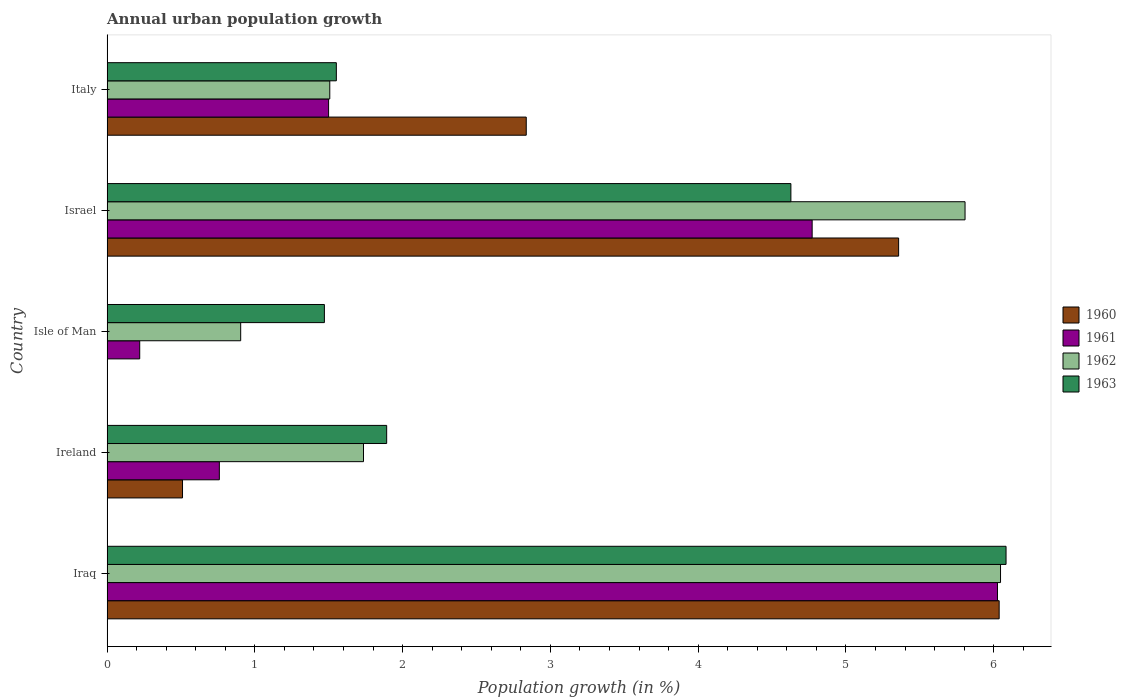Are the number of bars per tick equal to the number of legend labels?
Offer a very short reply. No. Are the number of bars on each tick of the Y-axis equal?
Offer a very short reply. No. How many bars are there on the 1st tick from the bottom?
Give a very brief answer. 4. What is the percentage of urban population growth in 1960 in Italy?
Your answer should be very brief. 2.84. Across all countries, what is the maximum percentage of urban population growth in 1962?
Provide a succinct answer. 6.05. Across all countries, what is the minimum percentage of urban population growth in 1962?
Your answer should be very brief. 0.9. In which country was the percentage of urban population growth in 1960 maximum?
Provide a succinct answer. Iraq. What is the total percentage of urban population growth in 1963 in the graph?
Offer a very short reply. 15.62. What is the difference between the percentage of urban population growth in 1961 in Ireland and that in Isle of Man?
Offer a very short reply. 0.54. What is the difference between the percentage of urban population growth in 1961 in Italy and the percentage of urban population growth in 1960 in Iraq?
Provide a short and direct response. -4.54. What is the average percentage of urban population growth in 1962 per country?
Make the answer very short. 3.2. What is the difference between the percentage of urban population growth in 1963 and percentage of urban population growth in 1961 in Ireland?
Give a very brief answer. 1.13. What is the ratio of the percentage of urban population growth in 1963 in Iraq to that in Ireland?
Keep it short and to the point. 3.22. Is the percentage of urban population growth in 1962 in Isle of Man less than that in Italy?
Your response must be concise. Yes. What is the difference between the highest and the second highest percentage of urban population growth in 1960?
Provide a short and direct response. 0.68. What is the difference between the highest and the lowest percentage of urban population growth in 1963?
Give a very brief answer. 4.61. Is the sum of the percentage of urban population growth in 1962 in Ireland and Israel greater than the maximum percentage of urban population growth in 1963 across all countries?
Ensure brevity in your answer.  Yes. Is it the case that in every country, the sum of the percentage of urban population growth in 1960 and percentage of urban population growth in 1963 is greater than the percentage of urban population growth in 1962?
Your response must be concise. Yes. Are all the bars in the graph horizontal?
Make the answer very short. Yes. How many countries are there in the graph?
Give a very brief answer. 5. What is the difference between two consecutive major ticks on the X-axis?
Provide a short and direct response. 1. How are the legend labels stacked?
Give a very brief answer. Vertical. What is the title of the graph?
Provide a succinct answer. Annual urban population growth. What is the label or title of the X-axis?
Give a very brief answer. Population growth (in %). What is the Population growth (in %) of 1960 in Iraq?
Provide a short and direct response. 6.04. What is the Population growth (in %) in 1961 in Iraq?
Provide a succinct answer. 6.03. What is the Population growth (in %) of 1962 in Iraq?
Offer a terse response. 6.05. What is the Population growth (in %) in 1963 in Iraq?
Offer a terse response. 6.08. What is the Population growth (in %) of 1960 in Ireland?
Your answer should be compact. 0.51. What is the Population growth (in %) in 1961 in Ireland?
Give a very brief answer. 0.76. What is the Population growth (in %) in 1962 in Ireland?
Offer a very short reply. 1.74. What is the Population growth (in %) in 1963 in Ireland?
Provide a succinct answer. 1.89. What is the Population growth (in %) in 1960 in Isle of Man?
Ensure brevity in your answer.  0. What is the Population growth (in %) in 1961 in Isle of Man?
Provide a succinct answer. 0.22. What is the Population growth (in %) of 1962 in Isle of Man?
Give a very brief answer. 0.9. What is the Population growth (in %) of 1963 in Isle of Man?
Your answer should be compact. 1.47. What is the Population growth (in %) of 1960 in Israel?
Your answer should be compact. 5.36. What is the Population growth (in %) in 1961 in Israel?
Your answer should be very brief. 4.77. What is the Population growth (in %) in 1962 in Israel?
Provide a succinct answer. 5.81. What is the Population growth (in %) in 1963 in Israel?
Give a very brief answer. 4.63. What is the Population growth (in %) in 1960 in Italy?
Provide a succinct answer. 2.84. What is the Population growth (in %) in 1961 in Italy?
Provide a short and direct response. 1.5. What is the Population growth (in %) in 1962 in Italy?
Offer a very short reply. 1.51. What is the Population growth (in %) of 1963 in Italy?
Your answer should be very brief. 1.55. Across all countries, what is the maximum Population growth (in %) in 1960?
Your answer should be very brief. 6.04. Across all countries, what is the maximum Population growth (in %) of 1961?
Make the answer very short. 6.03. Across all countries, what is the maximum Population growth (in %) of 1962?
Make the answer very short. 6.05. Across all countries, what is the maximum Population growth (in %) of 1963?
Provide a short and direct response. 6.08. Across all countries, what is the minimum Population growth (in %) of 1960?
Offer a terse response. 0. Across all countries, what is the minimum Population growth (in %) in 1961?
Keep it short and to the point. 0.22. Across all countries, what is the minimum Population growth (in %) in 1962?
Ensure brevity in your answer.  0.9. Across all countries, what is the minimum Population growth (in %) of 1963?
Keep it short and to the point. 1.47. What is the total Population growth (in %) of 1960 in the graph?
Give a very brief answer. 14.74. What is the total Population growth (in %) in 1961 in the graph?
Keep it short and to the point. 13.28. What is the total Population growth (in %) of 1962 in the graph?
Give a very brief answer. 16. What is the total Population growth (in %) of 1963 in the graph?
Ensure brevity in your answer.  15.62. What is the difference between the Population growth (in %) of 1960 in Iraq and that in Ireland?
Keep it short and to the point. 5.53. What is the difference between the Population growth (in %) of 1961 in Iraq and that in Ireland?
Make the answer very short. 5.27. What is the difference between the Population growth (in %) in 1962 in Iraq and that in Ireland?
Your answer should be very brief. 4.31. What is the difference between the Population growth (in %) of 1963 in Iraq and that in Ireland?
Keep it short and to the point. 4.19. What is the difference between the Population growth (in %) in 1961 in Iraq and that in Isle of Man?
Keep it short and to the point. 5.8. What is the difference between the Population growth (in %) in 1962 in Iraq and that in Isle of Man?
Provide a short and direct response. 5.14. What is the difference between the Population growth (in %) in 1963 in Iraq and that in Isle of Man?
Offer a very short reply. 4.61. What is the difference between the Population growth (in %) of 1960 in Iraq and that in Israel?
Your response must be concise. 0.68. What is the difference between the Population growth (in %) in 1961 in Iraq and that in Israel?
Offer a terse response. 1.25. What is the difference between the Population growth (in %) of 1962 in Iraq and that in Israel?
Provide a succinct answer. 0.24. What is the difference between the Population growth (in %) of 1963 in Iraq and that in Israel?
Provide a succinct answer. 1.46. What is the difference between the Population growth (in %) of 1960 in Iraq and that in Italy?
Make the answer very short. 3.2. What is the difference between the Population growth (in %) of 1961 in Iraq and that in Italy?
Make the answer very short. 4.53. What is the difference between the Population growth (in %) of 1962 in Iraq and that in Italy?
Provide a succinct answer. 4.54. What is the difference between the Population growth (in %) of 1963 in Iraq and that in Italy?
Your response must be concise. 4.53. What is the difference between the Population growth (in %) in 1961 in Ireland and that in Isle of Man?
Your answer should be compact. 0.54. What is the difference between the Population growth (in %) in 1962 in Ireland and that in Isle of Man?
Your answer should be compact. 0.83. What is the difference between the Population growth (in %) of 1963 in Ireland and that in Isle of Man?
Make the answer very short. 0.42. What is the difference between the Population growth (in %) of 1960 in Ireland and that in Israel?
Make the answer very short. -4.85. What is the difference between the Population growth (in %) in 1961 in Ireland and that in Israel?
Make the answer very short. -4.01. What is the difference between the Population growth (in %) of 1962 in Ireland and that in Israel?
Ensure brevity in your answer.  -4.07. What is the difference between the Population growth (in %) of 1963 in Ireland and that in Israel?
Offer a terse response. -2.74. What is the difference between the Population growth (in %) in 1960 in Ireland and that in Italy?
Your answer should be very brief. -2.33. What is the difference between the Population growth (in %) of 1961 in Ireland and that in Italy?
Your response must be concise. -0.74. What is the difference between the Population growth (in %) of 1962 in Ireland and that in Italy?
Provide a short and direct response. 0.23. What is the difference between the Population growth (in %) of 1963 in Ireland and that in Italy?
Provide a short and direct response. 0.34. What is the difference between the Population growth (in %) in 1961 in Isle of Man and that in Israel?
Give a very brief answer. -4.55. What is the difference between the Population growth (in %) of 1962 in Isle of Man and that in Israel?
Make the answer very short. -4.9. What is the difference between the Population growth (in %) in 1963 in Isle of Man and that in Israel?
Give a very brief answer. -3.16. What is the difference between the Population growth (in %) in 1961 in Isle of Man and that in Italy?
Make the answer very short. -1.28. What is the difference between the Population growth (in %) in 1962 in Isle of Man and that in Italy?
Provide a succinct answer. -0.6. What is the difference between the Population growth (in %) in 1963 in Isle of Man and that in Italy?
Your response must be concise. -0.08. What is the difference between the Population growth (in %) in 1960 in Israel and that in Italy?
Your response must be concise. 2.52. What is the difference between the Population growth (in %) of 1961 in Israel and that in Italy?
Provide a short and direct response. 3.27. What is the difference between the Population growth (in %) of 1962 in Israel and that in Italy?
Make the answer very short. 4.3. What is the difference between the Population growth (in %) in 1963 in Israel and that in Italy?
Your response must be concise. 3.08. What is the difference between the Population growth (in %) in 1960 in Iraq and the Population growth (in %) in 1961 in Ireland?
Your answer should be very brief. 5.28. What is the difference between the Population growth (in %) of 1960 in Iraq and the Population growth (in %) of 1962 in Ireland?
Give a very brief answer. 4.3. What is the difference between the Population growth (in %) in 1960 in Iraq and the Population growth (in %) in 1963 in Ireland?
Offer a very short reply. 4.14. What is the difference between the Population growth (in %) of 1961 in Iraq and the Population growth (in %) of 1962 in Ireland?
Your response must be concise. 4.29. What is the difference between the Population growth (in %) of 1961 in Iraq and the Population growth (in %) of 1963 in Ireland?
Offer a terse response. 4.13. What is the difference between the Population growth (in %) of 1962 in Iraq and the Population growth (in %) of 1963 in Ireland?
Ensure brevity in your answer.  4.15. What is the difference between the Population growth (in %) in 1960 in Iraq and the Population growth (in %) in 1961 in Isle of Man?
Offer a terse response. 5.82. What is the difference between the Population growth (in %) of 1960 in Iraq and the Population growth (in %) of 1962 in Isle of Man?
Your response must be concise. 5.13. What is the difference between the Population growth (in %) of 1960 in Iraq and the Population growth (in %) of 1963 in Isle of Man?
Offer a very short reply. 4.57. What is the difference between the Population growth (in %) of 1961 in Iraq and the Population growth (in %) of 1962 in Isle of Man?
Your answer should be compact. 5.12. What is the difference between the Population growth (in %) in 1961 in Iraq and the Population growth (in %) in 1963 in Isle of Man?
Offer a terse response. 4.55. What is the difference between the Population growth (in %) in 1962 in Iraq and the Population growth (in %) in 1963 in Isle of Man?
Your answer should be very brief. 4.58. What is the difference between the Population growth (in %) in 1960 in Iraq and the Population growth (in %) in 1961 in Israel?
Offer a very short reply. 1.27. What is the difference between the Population growth (in %) in 1960 in Iraq and the Population growth (in %) in 1962 in Israel?
Your response must be concise. 0.23. What is the difference between the Population growth (in %) of 1960 in Iraq and the Population growth (in %) of 1963 in Israel?
Your answer should be compact. 1.41. What is the difference between the Population growth (in %) of 1961 in Iraq and the Population growth (in %) of 1962 in Israel?
Make the answer very short. 0.22. What is the difference between the Population growth (in %) of 1961 in Iraq and the Population growth (in %) of 1963 in Israel?
Offer a terse response. 1.4. What is the difference between the Population growth (in %) in 1962 in Iraq and the Population growth (in %) in 1963 in Israel?
Ensure brevity in your answer.  1.42. What is the difference between the Population growth (in %) in 1960 in Iraq and the Population growth (in %) in 1961 in Italy?
Your answer should be very brief. 4.54. What is the difference between the Population growth (in %) of 1960 in Iraq and the Population growth (in %) of 1962 in Italy?
Ensure brevity in your answer.  4.53. What is the difference between the Population growth (in %) of 1960 in Iraq and the Population growth (in %) of 1963 in Italy?
Your answer should be compact. 4.49. What is the difference between the Population growth (in %) of 1961 in Iraq and the Population growth (in %) of 1962 in Italy?
Your answer should be very brief. 4.52. What is the difference between the Population growth (in %) in 1961 in Iraq and the Population growth (in %) in 1963 in Italy?
Provide a succinct answer. 4.47. What is the difference between the Population growth (in %) in 1962 in Iraq and the Population growth (in %) in 1963 in Italy?
Provide a short and direct response. 4.49. What is the difference between the Population growth (in %) in 1960 in Ireland and the Population growth (in %) in 1961 in Isle of Man?
Give a very brief answer. 0.29. What is the difference between the Population growth (in %) in 1960 in Ireland and the Population growth (in %) in 1962 in Isle of Man?
Keep it short and to the point. -0.39. What is the difference between the Population growth (in %) in 1960 in Ireland and the Population growth (in %) in 1963 in Isle of Man?
Provide a succinct answer. -0.96. What is the difference between the Population growth (in %) of 1961 in Ireland and the Population growth (in %) of 1962 in Isle of Man?
Your answer should be compact. -0.14. What is the difference between the Population growth (in %) in 1961 in Ireland and the Population growth (in %) in 1963 in Isle of Man?
Keep it short and to the point. -0.71. What is the difference between the Population growth (in %) of 1962 in Ireland and the Population growth (in %) of 1963 in Isle of Man?
Give a very brief answer. 0.26. What is the difference between the Population growth (in %) of 1960 in Ireland and the Population growth (in %) of 1961 in Israel?
Provide a succinct answer. -4.26. What is the difference between the Population growth (in %) in 1960 in Ireland and the Population growth (in %) in 1962 in Israel?
Provide a short and direct response. -5.3. What is the difference between the Population growth (in %) of 1960 in Ireland and the Population growth (in %) of 1963 in Israel?
Offer a very short reply. -4.12. What is the difference between the Population growth (in %) in 1961 in Ireland and the Population growth (in %) in 1962 in Israel?
Give a very brief answer. -5.05. What is the difference between the Population growth (in %) of 1961 in Ireland and the Population growth (in %) of 1963 in Israel?
Ensure brevity in your answer.  -3.87. What is the difference between the Population growth (in %) in 1962 in Ireland and the Population growth (in %) in 1963 in Israel?
Make the answer very short. -2.89. What is the difference between the Population growth (in %) of 1960 in Ireland and the Population growth (in %) of 1961 in Italy?
Offer a terse response. -0.99. What is the difference between the Population growth (in %) of 1960 in Ireland and the Population growth (in %) of 1962 in Italy?
Provide a succinct answer. -1. What is the difference between the Population growth (in %) of 1960 in Ireland and the Population growth (in %) of 1963 in Italy?
Provide a short and direct response. -1.04. What is the difference between the Population growth (in %) in 1961 in Ireland and the Population growth (in %) in 1962 in Italy?
Give a very brief answer. -0.75. What is the difference between the Population growth (in %) in 1961 in Ireland and the Population growth (in %) in 1963 in Italy?
Offer a terse response. -0.79. What is the difference between the Population growth (in %) of 1962 in Ireland and the Population growth (in %) of 1963 in Italy?
Your answer should be very brief. 0.18. What is the difference between the Population growth (in %) in 1961 in Isle of Man and the Population growth (in %) in 1962 in Israel?
Make the answer very short. -5.59. What is the difference between the Population growth (in %) in 1961 in Isle of Man and the Population growth (in %) in 1963 in Israel?
Offer a very short reply. -4.41. What is the difference between the Population growth (in %) of 1962 in Isle of Man and the Population growth (in %) of 1963 in Israel?
Provide a succinct answer. -3.72. What is the difference between the Population growth (in %) of 1961 in Isle of Man and the Population growth (in %) of 1962 in Italy?
Keep it short and to the point. -1.29. What is the difference between the Population growth (in %) of 1961 in Isle of Man and the Population growth (in %) of 1963 in Italy?
Give a very brief answer. -1.33. What is the difference between the Population growth (in %) of 1962 in Isle of Man and the Population growth (in %) of 1963 in Italy?
Your answer should be compact. -0.65. What is the difference between the Population growth (in %) in 1960 in Israel and the Population growth (in %) in 1961 in Italy?
Ensure brevity in your answer.  3.86. What is the difference between the Population growth (in %) of 1960 in Israel and the Population growth (in %) of 1962 in Italy?
Offer a terse response. 3.85. What is the difference between the Population growth (in %) in 1960 in Israel and the Population growth (in %) in 1963 in Italy?
Ensure brevity in your answer.  3.8. What is the difference between the Population growth (in %) in 1961 in Israel and the Population growth (in %) in 1962 in Italy?
Provide a succinct answer. 3.26. What is the difference between the Population growth (in %) in 1961 in Israel and the Population growth (in %) in 1963 in Italy?
Your answer should be compact. 3.22. What is the difference between the Population growth (in %) of 1962 in Israel and the Population growth (in %) of 1963 in Italy?
Offer a terse response. 4.25. What is the average Population growth (in %) of 1960 per country?
Offer a terse response. 2.95. What is the average Population growth (in %) in 1961 per country?
Your response must be concise. 2.66. What is the average Population growth (in %) of 1962 per country?
Your answer should be compact. 3.2. What is the average Population growth (in %) in 1963 per country?
Your response must be concise. 3.12. What is the difference between the Population growth (in %) of 1960 and Population growth (in %) of 1961 in Iraq?
Offer a terse response. 0.01. What is the difference between the Population growth (in %) of 1960 and Population growth (in %) of 1962 in Iraq?
Ensure brevity in your answer.  -0.01. What is the difference between the Population growth (in %) of 1960 and Population growth (in %) of 1963 in Iraq?
Your answer should be compact. -0.05. What is the difference between the Population growth (in %) in 1961 and Population growth (in %) in 1962 in Iraq?
Your response must be concise. -0.02. What is the difference between the Population growth (in %) of 1961 and Population growth (in %) of 1963 in Iraq?
Make the answer very short. -0.06. What is the difference between the Population growth (in %) in 1962 and Population growth (in %) in 1963 in Iraq?
Ensure brevity in your answer.  -0.04. What is the difference between the Population growth (in %) in 1960 and Population growth (in %) in 1961 in Ireland?
Your answer should be very brief. -0.25. What is the difference between the Population growth (in %) in 1960 and Population growth (in %) in 1962 in Ireland?
Provide a short and direct response. -1.22. What is the difference between the Population growth (in %) in 1960 and Population growth (in %) in 1963 in Ireland?
Your response must be concise. -1.38. What is the difference between the Population growth (in %) of 1961 and Population growth (in %) of 1962 in Ireland?
Provide a succinct answer. -0.98. What is the difference between the Population growth (in %) in 1961 and Population growth (in %) in 1963 in Ireland?
Keep it short and to the point. -1.13. What is the difference between the Population growth (in %) in 1962 and Population growth (in %) in 1963 in Ireland?
Ensure brevity in your answer.  -0.16. What is the difference between the Population growth (in %) in 1961 and Population growth (in %) in 1962 in Isle of Man?
Your response must be concise. -0.68. What is the difference between the Population growth (in %) in 1961 and Population growth (in %) in 1963 in Isle of Man?
Keep it short and to the point. -1.25. What is the difference between the Population growth (in %) in 1962 and Population growth (in %) in 1963 in Isle of Man?
Offer a very short reply. -0.57. What is the difference between the Population growth (in %) in 1960 and Population growth (in %) in 1961 in Israel?
Provide a succinct answer. 0.59. What is the difference between the Population growth (in %) in 1960 and Population growth (in %) in 1962 in Israel?
Ensure brevity in your answer.  -0.45. What is the difference between the Population growth (in %) in 1960 and Population growth (in %) in 1963 in Israel?
Keep it short and to the point. 0.73. What is the difference between the Population growth (in %) of 1961 and Population growth (in %) of 1962 in Israel?
Provide a succinct answer. -1.03. What is the difference between the Population growth (in %) of 1961 and Population growth (in %) of 1963 in Israel?
Provide a succinct answer. 0.14. What is the difference between the Population growth (in %) in 1962 and Population growth (in %) in 1963 in Israel?
Ensure brevity in your answer.  1.18. What is the difference between the Population growth (in %) of 1960 and Population growth (in %) of 1961 in Italy?
Your answer should be compact. 1.34. What is the difference between the Population growth (in %) of 1960 and Population growth (in %) of 1962 in Italy?
Ensure brevity in your answer.  1.33. What is the difference between the Population growth (in %) of 1960 and Population growth (in %) of 1963 in Italy?
Make the answer very short. 1.29. What is the difference between the Population growth (in %) of 1961 and Population growth (in %) of 1962 in Italy?
Provide a succinct answer. -0.01. What is the difference between the Population growth (in %) in 1961 and Population growth (in %) in 1963 in Italy?
Keep it short and to the point. -0.05. What is the difference between the Population growth (in %) of 1962 and Population growth (in %) of 1963 in Italy?
Make the answer very short. -0.04. What is the ratio of the Population growth (in %) in 1960 in Iraq to that in Ireland?
Provide a short and direct response. 11.83. What is the ratio of the Population growth (in %) in 1961 in Iraq to that in Ireland?
Ensure brevity in your answer.  7.93. What is the ratio of the Population growth (in %) in 1962 in Iraq to that in Ireland?
Offer a terse response. 3.48. What is the ratio of the Population growth (in %) in 1963 in Iraq to that in Ireland?
Ensure brevity in your answer.  3.22. What is the ratio of the Population growth (in %) of 1961 in Iraq to that in Isle of Man?
Your answer should be compact. 27.3. What is the ratio of the Population growth (in %) in 1962 in Iraq to that in Isle of Man?
Keep it short and to the point. 6.69. What is the ratio of the Population growth (in %) in 1963 in Iraq to that in Isle of Man?
Your answer should be compact. 4.14. What is the ratio of the Population growth (in %) in 1960 in Iraq to that in Israel?
Your answer should be compact. 1.13. What is the ratio of the Population growth (in %) in 1961 in Iraq to that in Israel?
Your answer should be very brief. 1.26. What is the ratio of the Population growth (in %) of 1962 in Iraq to that in Israel?
Offer a terse response. 1.04. What is the ratio of the Population growth (in %) in 1963 in Iraq to that in Israel?
Provide a succinct answer. 1.31. What is the ratio of the Population growth (in %) of 1960 in Iraq to that in Italy?
Your answer should be very brief. 2.13. What is the ratio of the Population growth (in %) of 1961 in Iraq to that in Italy?
Provide a short and direct response. 4.02. What is the ratio of the Population growth (in %) in 1962 in Iraq to that in Italy?
Provide a short and direct response. 4.01. What is the ratio of the Population growth (in %) in 1963 in Iraq to that in Italy?
Your response must be concise. 3.92. What is the ratio of the Population growth (in %) in 1961 in Ireland to that in Isle of Man?
Give a very brief answer. 3.44. What is the ratio of the Population growth (in %) of 1962 in Ireland to that in Isle of Man?
Your answer should be very brief. 1.92. What is the ratio of the Population growth (in %) of 1963 in Ireland to that in Isle of Man?
Your answer should be very brief. 1.29. What is the ratio of the Population growth (in %) in 1960 in Ireland to that in Israel?
Your answer should be compact. 0.1. What is the ratio of the Population growth (in %) in 1961 in Ireland to that in Israel?
Give a very brief answer. 0.16. What is the ratio of the Population growth (in %) of 1962 in Ireland to that in Israel?
Your answer should be very brief. 0.3. What is the ratio of the Population growth (in %) in 1963 in Ireland to that in Israel?
Provide a short and direct response. 0.41. What is the ratio of the Population growth (in %) in 1960 in Ireland to that in Italy?
Provide a succinct answer. 0.18. What is the ratio of the Population growth (in %) of 1961 in Ireland to that in Italy?
Provide a succinct answer. 0.51. What is the ratio of the Population growth (in %) in 1962 in Ireland to that in Italy?
Ensure brevity in your answer.  1.15. What is the ratio of the Population growth (in %) of 1963 in Ireland to that in Italy?
Provide a short and direct response. 1.22. What is the ratio of the Population growth (in %) of 1961 in Isle of Man to that in Israel?
Provide a short and direct response. 0.05. What is the ratio of the Population growth (in %) of 1962 in Isle of Man to that in Israel?
Offer a very short reply. 0.16. What is the ratio of the Population growth (in %) of 1963 in Isle of Man to that in Israel?
Your response must be concise. 0.32. What is the ratio of the Population growth (in %) in 1961 in Isle of Man to that in Italy?
Provide a short and direct response. 0.15. What is the ratio of the Population growth (in %) in 1962 in Isle of Man to that in Italy?
Your response must be concise. 0.6. What is the ratio of the Population growth (in %) in 1963 in Isle of Man to that in Italy?
Your answer should be very brief. 0.95. What is the ratio of the Population growth (in %) of 1960 in Israel to that in Italy?
Ensure brevity in your answer.  1.89. What is the ratio of the Population growth (in %) of 1961 in Israel to that in Italy?
Keep it short and to the point. 3.18. What is the ratio of the Population growth (in %) of 1962 in Israel to that in Italy?
Your answer should be very brief. 3.85. What is the ratio of the Population growth (in %) in 1963 in Israel to that in Italy?
Provide a short and direct response. 2.98. What is the difference between the highest and the second highest Population growth (in %) in 1960?
Give a very brief answer. 0.68. What is the difference between the highest and the second highest Population growth (in %) of 1961?
Offer a very short reply. 1.25. What is the difference between the highest and the second highest Population growth (in %) in 1962?
Your answer should be very brief. 0.24. What is the difference between the highest and the second highest Population growth (in %) of 1963?
Offer a very short reply. 1.46. What is the difference between the highest and the lowest Population growth (in %) in 1960?
Provide a short and direct response. 6.04. What is the difference between the highest and the lowest Population growth (in %) in 1961?
Your response must be concise. 5.8. What is the difference between the highest and the lowest Population growth (in %) in 1962?
Give a very brief answer. 5.14. What is the difference between the highest and the lowest Population growth (in %) of 1963?
Your answer should be compact. 4.61. 